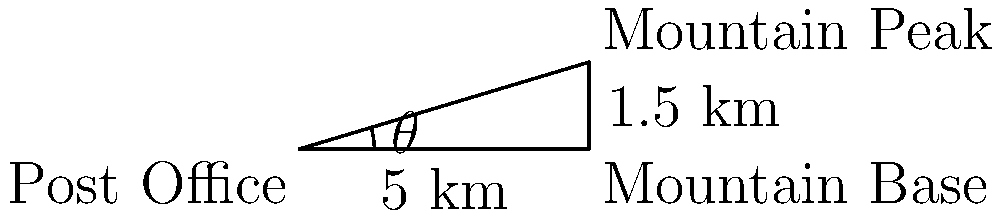From the post office, you observe a distant mountain peak. The base of the mountain is 5 km away from the post office, and the peak is 1.5 km higher than its base. What is the angle of elevation (in degrees) from the post office to the mountain peak? To solve this problem, we'll use trigonometry:

1) First, let's identify the triangle formed:
   - The base of the triangle is the distance from the post office to the mountain base (5 km)
   - The height is the difference in elevation (1.5 km)
   - The hypotenuse is the line of sight from the post office to the mountain peak

2) We're looking for the angle of elevation, which is the angle between the base and the hypotenuse.

3) This forms a right-angled triangle, so we can use the tangent function:

   $\tan(\theta) = \frac{\text{opposite}}{\text{adjacent}} = \frac{\text{height}}{\text{base}} = \frac{1.5}{5}$

4) To find $\theta$, we need to use the inverse tangent (arctan) function:

   $\theta = \arctan(\frac{1.5}{5})$

5) Using a calculator or mathematical tables:

   $\theta \approx 16.70^\circ$

6) Rounding to the nearest degree:

   $\theta \approx 17^\circ$

Thus, the angle of elevation from the post office to the mountain peak is approximately 17 degrees.
Answer: $17^\circ$ 